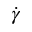Convert formula to latex. <formula><loc_0><loc_0><loc_500><loc_500>\dot { \gamma }</formula> 